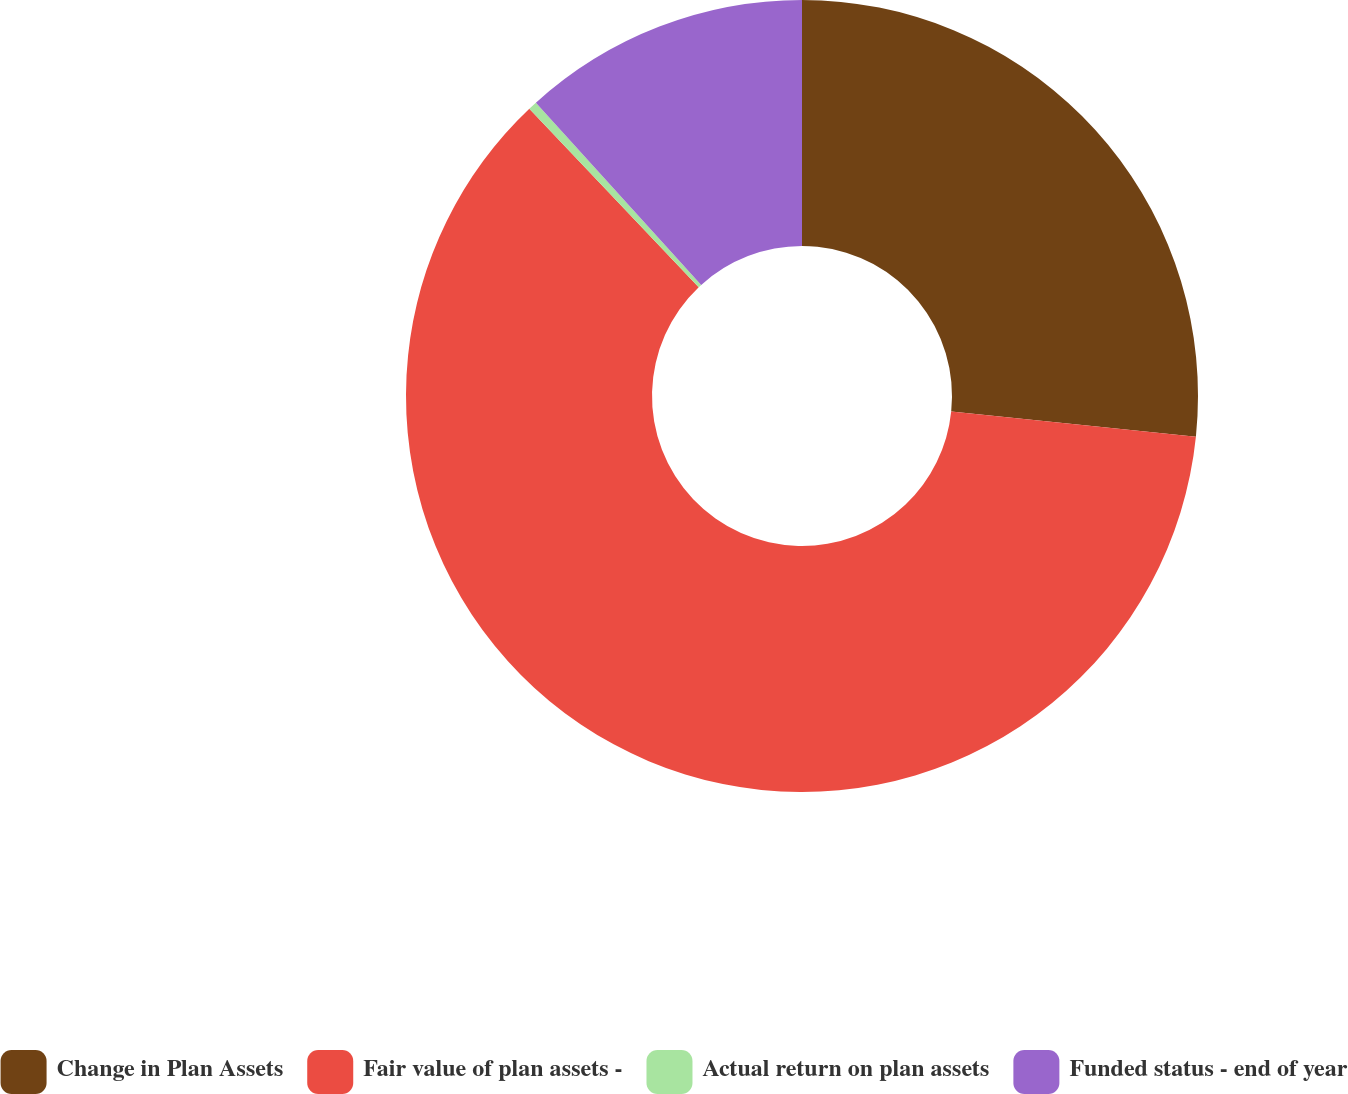<chart> <loc_0><loc_0><loc_500><loc_500><pie_chart><fcel>Change in Plan Assets<fcel>Fair value of plan assets -<fcel>Actual return on plan assets<fcel>Funded status - end of year<nl><fcel>26.64%<fcel>61.28%<fcel>0.36%<fcel>11.73%<nl></chart> 